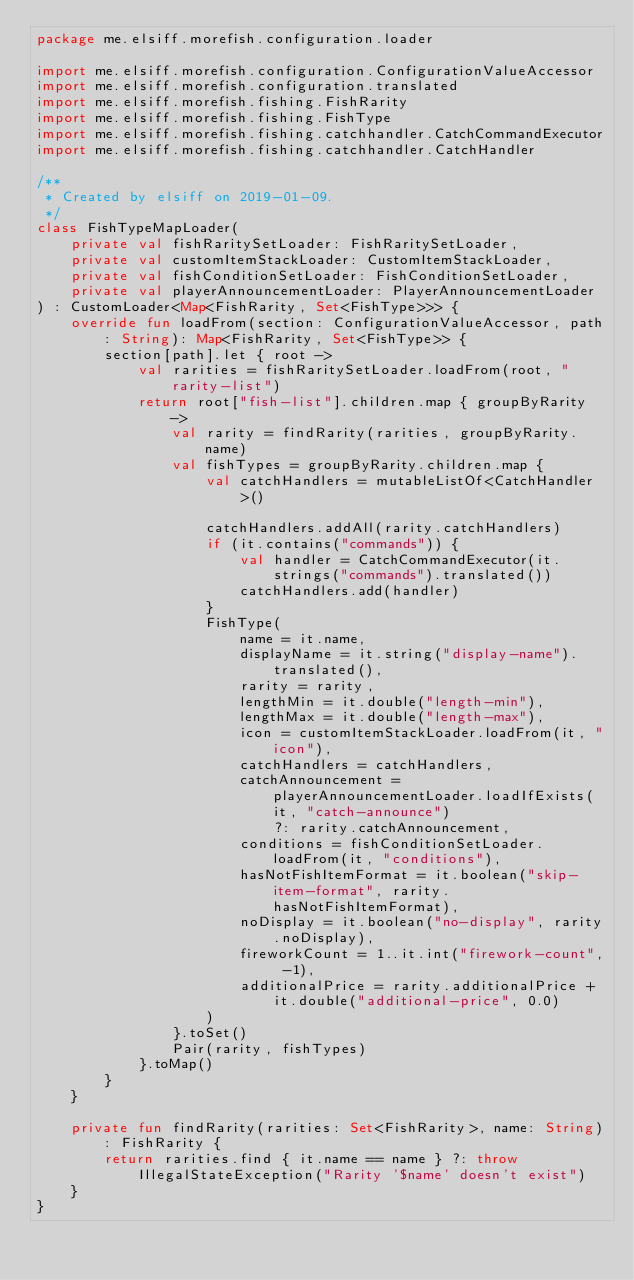<code> <loc_0><loc_0><loc_500><loc_500><_Kotlin_>package me.elsiff.morefish.configuration.loader

import me.elsiff.morefish.configuration.ConfigurationValueAccessor
import me.elsiff.morefish.configuration.translated
import me.elsiff.morefish.fishing.FishRarity
import me.elsiff.morefish.fishing.FishType
import me.elsiff.morefish.fishing.catchhandler.CatchCommandExecutor
import me.elsiff.morefish.fishing.catchhandler.CatchHandler

/**
 * Created by elsiff on 2019-01-09.
 */
class FishTypeMapLoader(
    private val fishRaritySetLoader: FishRaritySetLoader,
    private val customItemStackLoader: CustomItemStackLoader,
    private val fishConditionSetLoader: FishConditionSetLoader,
    private val playerAnnouncementLoader: PlayerAnnouncementLoader
) : CustomLoader<Map<FishRarity, Set<FishType>>> {
    override fun loadFrom(section: ConfigurationValueAccessor, path: String): Map<FishRarity, Set<FishType>> {
        section[path].let { root ->
            val rarities = fishRaritySetLoader.loadFrom(root, "rarity-list")
            return root["fish-list"].children.map { groupByRarity ->
                val rarity = findRarity(rarities, groupByRarity.name)
                val fishTypes = groupByRarity.children.map {
                    val catchHandlers = mutableListOf<CatchHandler>()

                    catchHandlers.addAll(rarity.catchHandlers)
                    if (it.contains("commands")) {
                        val handler = CatchCommandExecutor(it.strings("commands").translated())
                        catchHandlers.add(handler)
                    }
                    FishType(
                        name = it.name,
                        displayName = it.string("display-name").translated(),
                        rarity = rarity,
                        lengthMin = it.double("length-min"),
                        lengthMax = it.double("length-max"),
                        icon = customItemStackLoader.loadFrom(it, "icon"),
                        catchHandlers = catchHandlers,
                        catchAnnouncement = playerAnnouncementLoader.loadIfExists(it, "catch-announce")
                            ?: rarity.catchAnnouncement,
                        conditions = fishConditionSetLoader.loadFrom(it, "conditions"),
                        hasNotFishItemFormat = it.boolean("skip-item-format", rarity.hasNotFishItemFormat),
                        noDisplay = it.boolean("no-display", rarity.noDisplay),
                        fireworkCount = 1..it.int("firework-count", -1),
                        additionalPrice = rarity.additionalPrice + it.double("additional-price", 0.0)
                    )
                }.toSet()
                Pair(rarity, fishTypes)
            }.toMap()
        }
    }

    private fun findRarity(rarities: Set<FishRarity>, name: String): FishRarity {
        return rarities.find { it.name == name } ?: throw IllegalStateException("Rarity '$name' doesn't exist")
    }
}</code> 